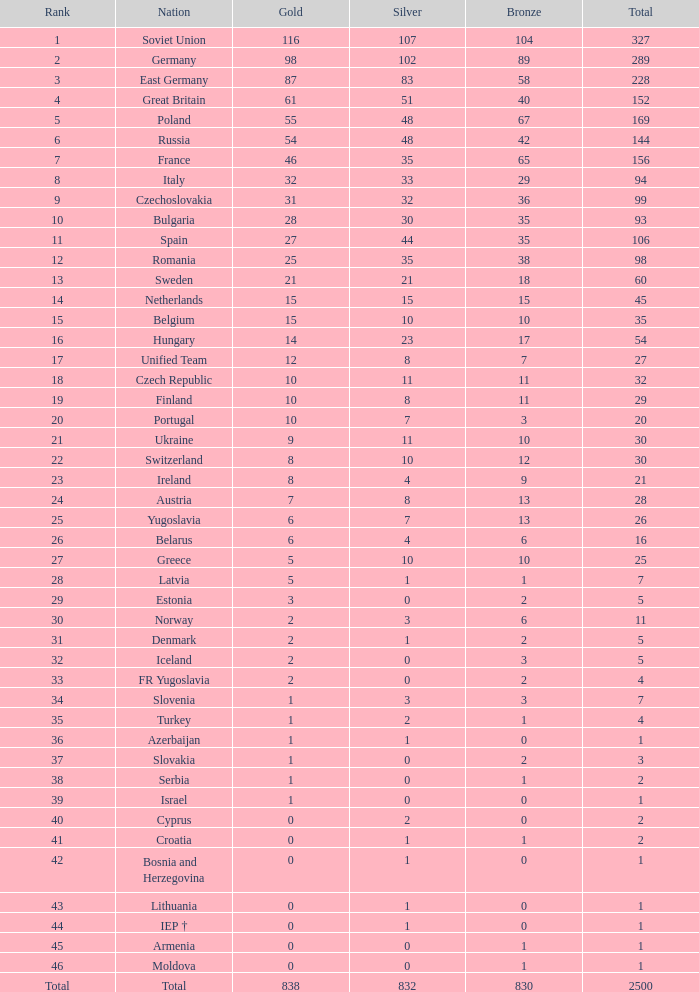What is the rank of the nation with more than 0 silver medals and 38 bronze medals? 12.0. 